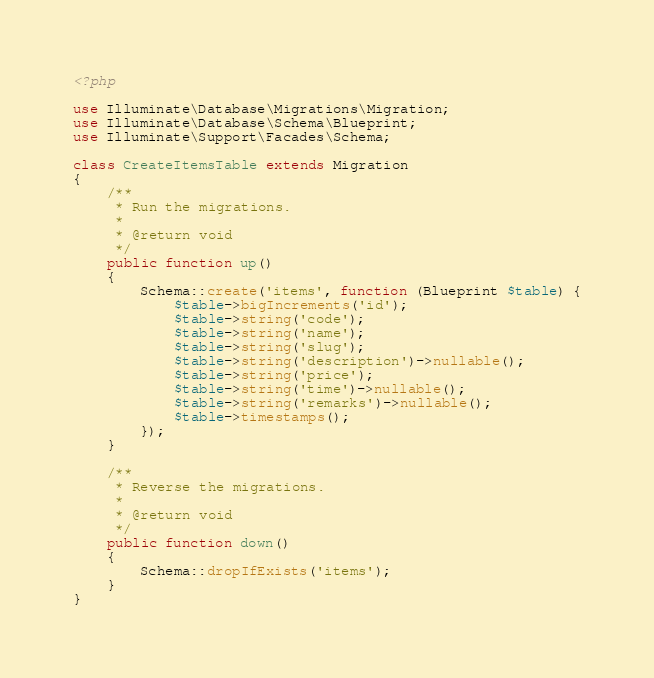<code> <loc_0><loc_0><loc_500><loc_500><_PHP_><?php

use Illuminate\Database\Migrations\Migration;
use Illuminate\Database\Schema\Blueprint;
use Illuminate\Support\Facades\Schema;

class CreateItemsTable extends Migration
{
    /**
     * Run the migrations.
     *
     * @return void
     */
    public function up()
    {
        Schema::create('items', function (Blueprint $table) {
            $table->bigIncrements('id');
            $table->string('code');
            $table->string('name');
            $table->string('slug');
            $table->string('description')->nullable();
            $table->string('price');
            $table->string('time')->nullable();
            $table->string('remarks')->nullable();
            $table->timestamps();
        });
    }

    /**
     * Reverse the migrations.
     *
     * @return void
     */
    public function down()
    {
        Schema::dropIfExists('items');
    }
}
</code> 